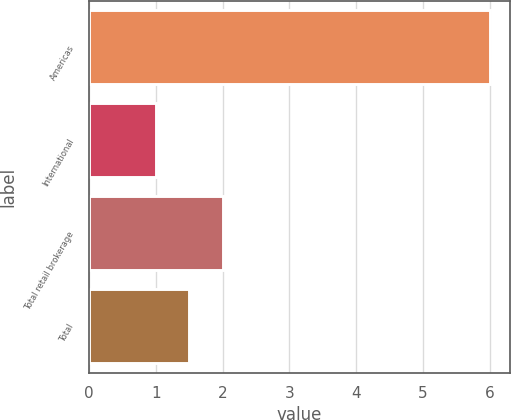Convert chart to OTSL. <chart><loc_0><loc_0><loc_500><loc_500><bar_chart><fcel>Americas<fcel>International<fcel>Total retail brokerage<fcel>Total<nl><fcel>6<fcel>1<fcel>2<fcel>1.5<nl></chart> 